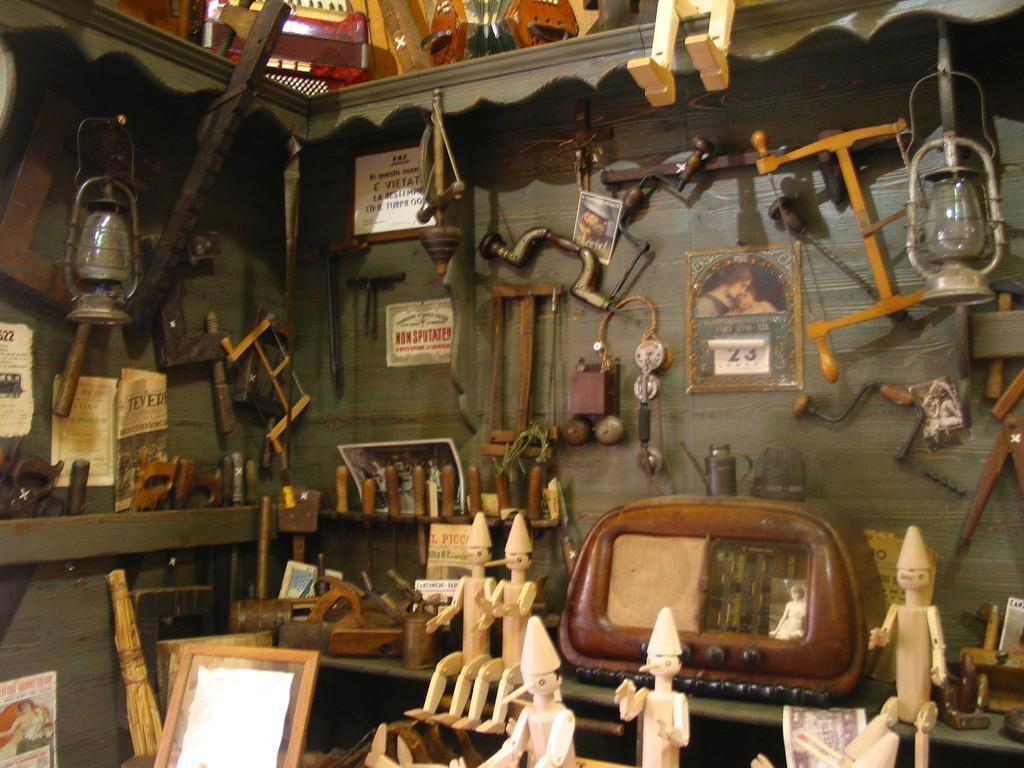Please provide a concise description of this image. In this image we can see wooden toys, radio, photo frame, tools, panthers, name board, posters and a few more things. Here we can see the wooden wall and some things kept on the top. 